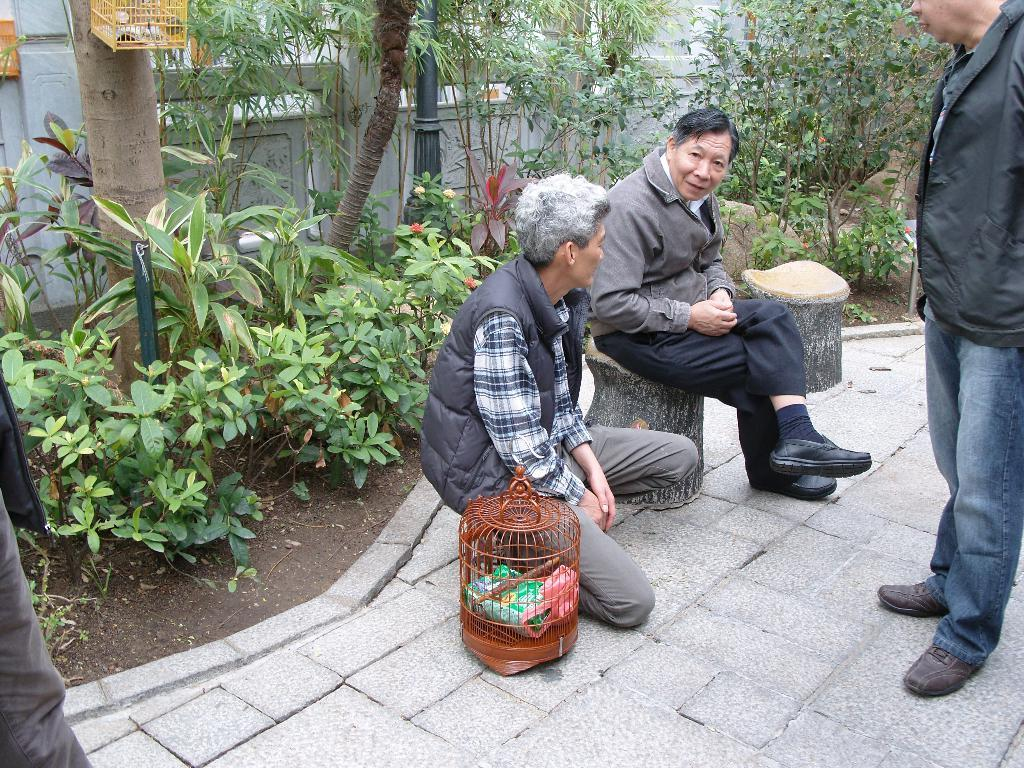How many people are present in the image? There are three persons in the image. What can be seen in the background of the image? There are plants and trees in the background of the image. What type of tomatoes can be seen growing on the card in the image? There are no tomatoes or cards present in the image. 